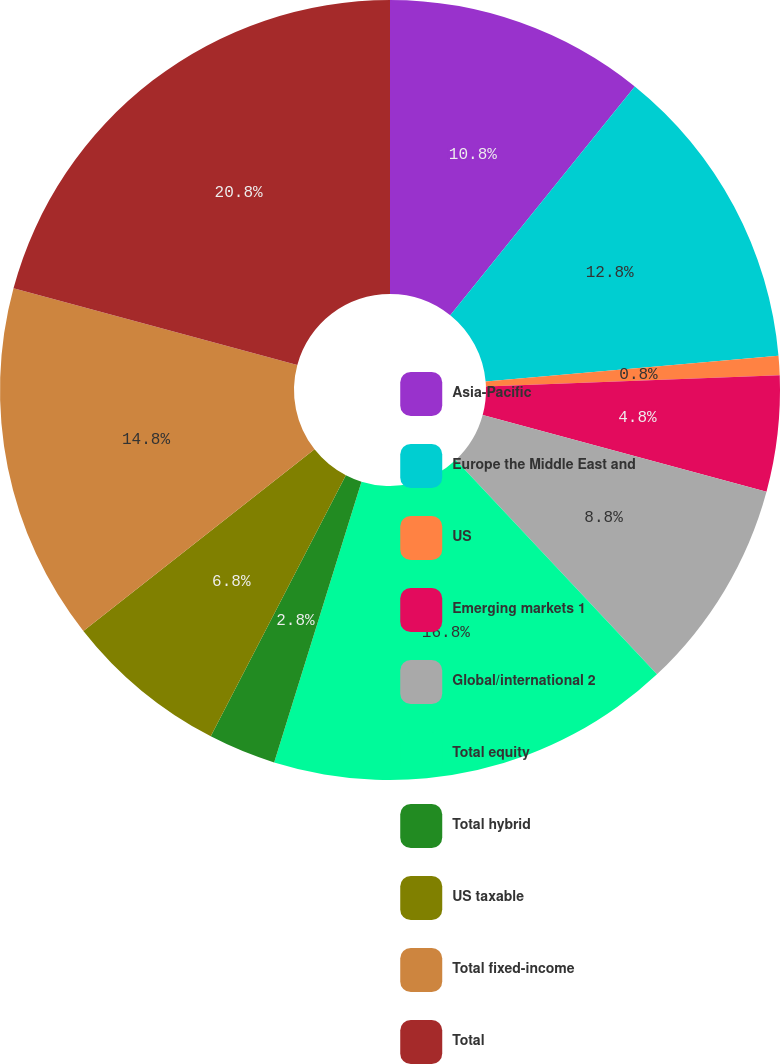Convert chart to OTSL. <chart><loc_0><loc_0><loc_500><loc_500><pie_chart><fcel>Asia-Pacific<fcel>Europe the Middle East and<fcel>US<fcel>Emerging markets 1<fcel>Global/international 2<fcel>Total equity<fcel>Total hybrid<fcel>US taxable<fcel>Total fixed-income<fcel>Total<nl><fcel>10.8%<fcel>12.8%<fcel>0.8%<fcel>4.8%<fcel>8.8%<fcel>16.8%<fcel>2.8%<fcel>6.8%<fcel>14.8%<fcel>20.8%<nl></chart> 